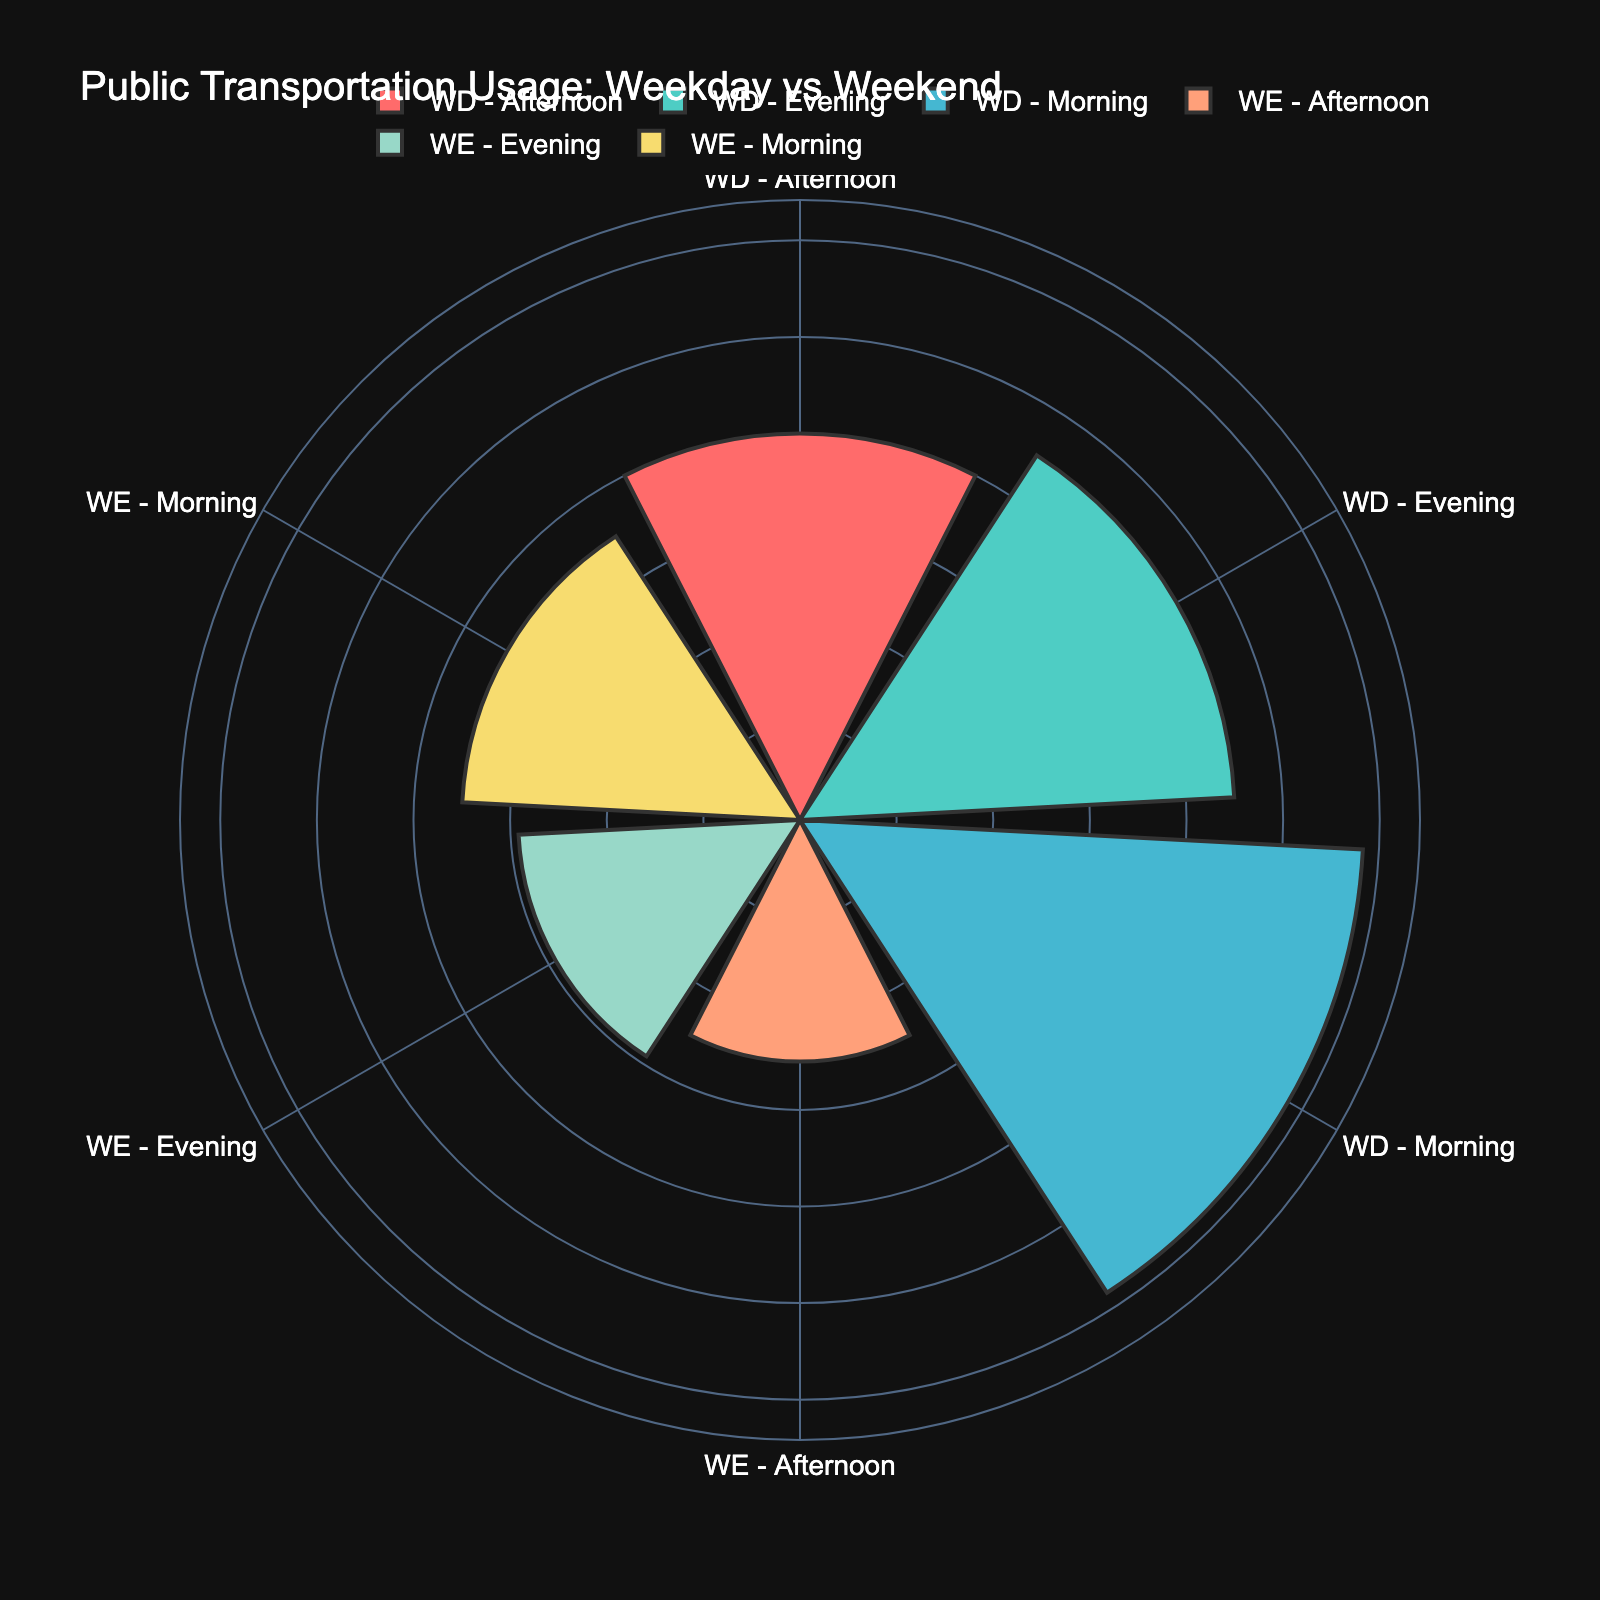What is the title of the chart? The title is usually displayed at the top of the chart and provides an overview of what the chart represents.
Answer: Public Transportation Usage: Weekday vs Weekend Which group has the highest average usage count? By examining the lengths of the bars in the rose chart, identify which segment extends the furthest from the center.
Answer: WD - Morning Which time of day shows the lowest average usage on weekdays? Compare segments labeled 'WD' and identify which one has the shortest bar.
Answer: WD - Afternoon What is the color used for 'WE - Evening'? Identify the distinct color associated with 'WE - Evening' in the polar chart.
Answer: Yellow (F7DC6F) Is the average usage count higher on weekdays or weekends for the morning slot? Compare the bar lengths for 'WD - Morning' and 'WE - Morning'.
Answer: Weekdays Calculate the average usage count for weekends across all time slots. Add up the usage counts for 'WE - Morning', 'WE - Afternoon', and 'WE - Evening' and divide by 3. (700 + 500 + 600) / 3 = 600
Answer: 600 Compare the average usage counts for 'WD - Evening' and 'WE - Evening'. Which is higher? Identify the bars for both groups and compare their lengths.
Answer: WD - Evening What time of day shows the largest difference in average usage count between weekdays and weekends? Calculate the differences for morning, afternoon, and evening by comparing 'WD' and 'WE' segments. Morning (1200-700=500), Afternoon (800-500=300), Evening (900-600=300). Morning has the largest difference.
Answer: Morning What insights can be drawn about public transportation usage trends from the chart? Summarize the visual patterns, higher usage on weekdays, and the impact of time of day on usage, among other observations.
Answer: Higher on weekdays, peaks in mornings, lower on weekends Estimate the number of data points represented in the chart. Based on the number of groups and segments, calculate the data points. Each WT-TO (Weekday vs Weekend-Time of day) combo for 3 locations totals to 18 (3 time slots x 2 categories x 3 locations).
Answer: 18 